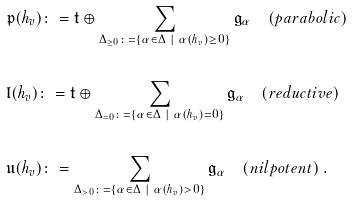<formula> <loc_0><loc_0><loc_500><loc_500>& \mathfrak { p } ( h _ { v } ) \colon = \mathfrak { t } \oplus \sum _ { \Delta _ { \geq 0 } \colon = \{ \alpha \in \Delta \ | \ \alpha ( h _ { v } ) \geq 0 \} } \mathfrak { g } _ { \alpha } \quad ( p a r a b o l i c ) \\ \ \\ & \mathfrak { l } ( h _ { v } ) \colon = \mathfrak { t } \oplus \sum _ { \Delta _ { = 0 } \colon = \{ \alpha \in \Delta \ | \ \alpha ( h _ { v } ) = 0 \} } \mathfrak { g } _ { \alpha } \quad ( r e d u c t i v e ) \\ \ \\ & \mathfrak { u } ( h _ { v } ) \colon = \sum _ { \Delta _ { > 0 } \colon = \{ \alpha \in \Delta \ | \ \alpha ( h _ { v } ) > 0 \} } \mathfrak { g } _ { \alpha } \quad ( n i l p o t e n t ) \ .</formula> 